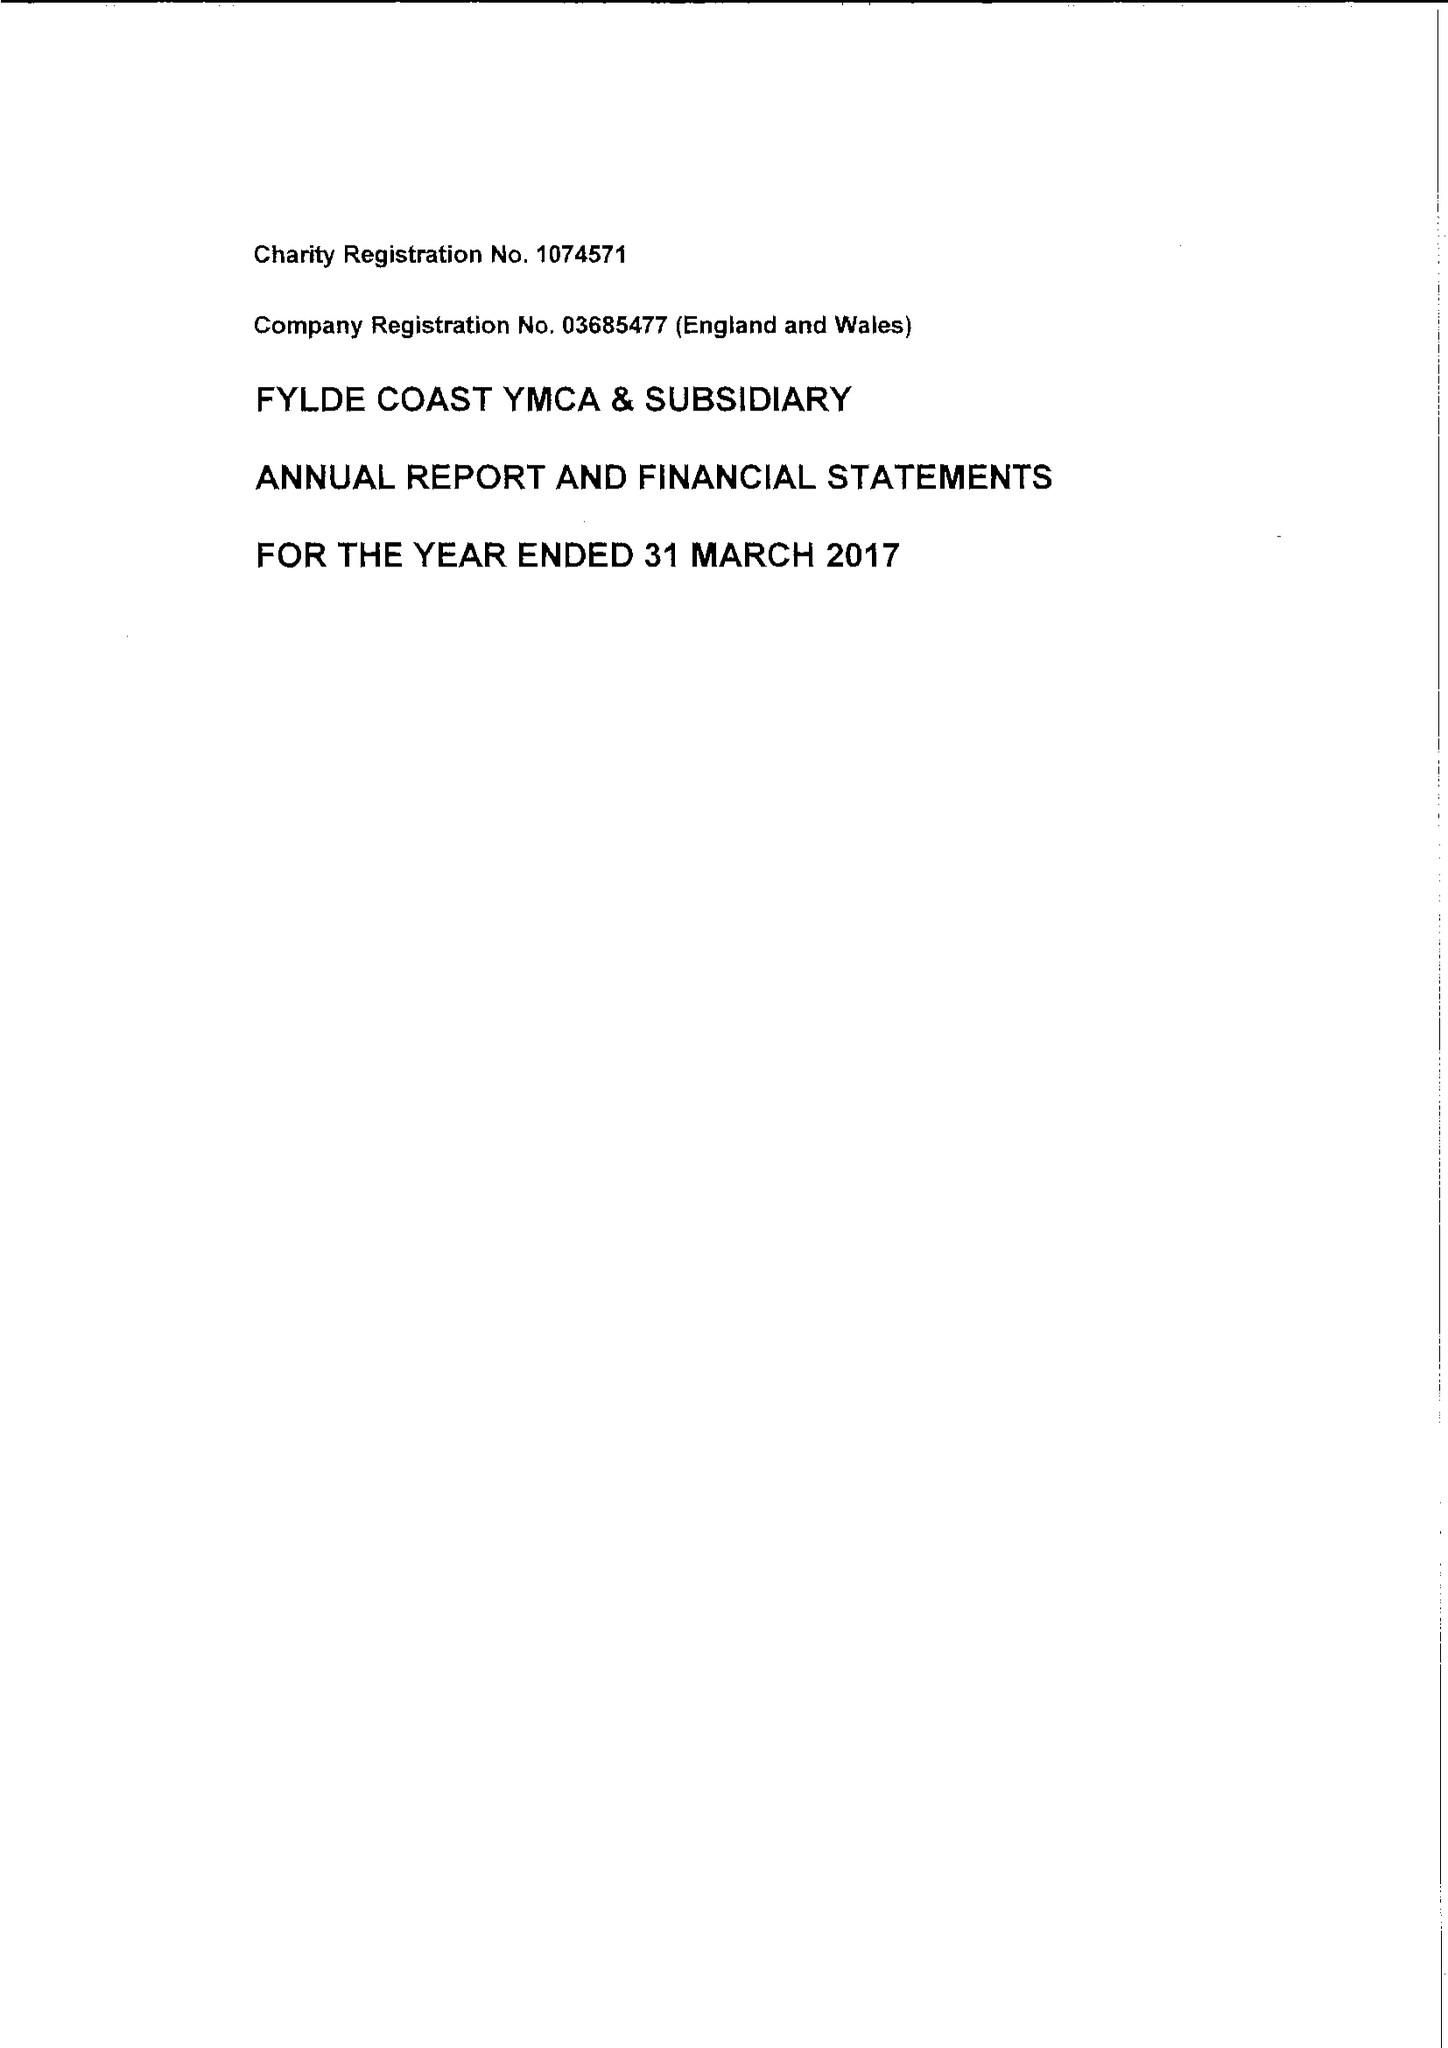What is the value for the address__postcode?
Answer the question using a single word or phrase. FY8 1XD 